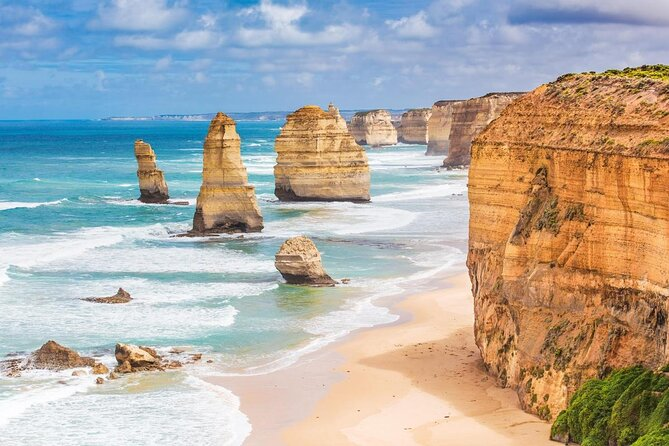What are some fun activities one could do in this area? The area around the Twelve Apostles offers a plethora of activities for visitors. You could take a scenic helicopter tour to get an aerial view of the majestic formations and the surrounding coastline. For those who enjoy hiking, the Great Ocean Walk offers stunning viewpoints and opportunities to explore the region's natural beauty. Beachcombing along the shores provides a chance to find unique shells and marine life. Surfing and swimming can be experienced at the nearby beaches, and don't forget to capture some breathtaking photographs to remember your visit by. For a more relaxed experience, you can simply sit and enjoy the serene environment, letting the sound of the crashing waves create a sense of peace and relaxation. I'm curious, can you tell me a fun fact about the Twelve Apostles? Absolutely! Did you know that despite the name, there were never exactly twelve stacks? The name 'Twelve Apostles' was attractively given to the site in the 1920s to draw tourists, but originally there were nine stacks. Over time, due to the erosive power of the ocean, some of these stacks have collapsed, and now only eight still stand tall. It's a testament to the dynamic and ever-changing nature of coastal geology. 